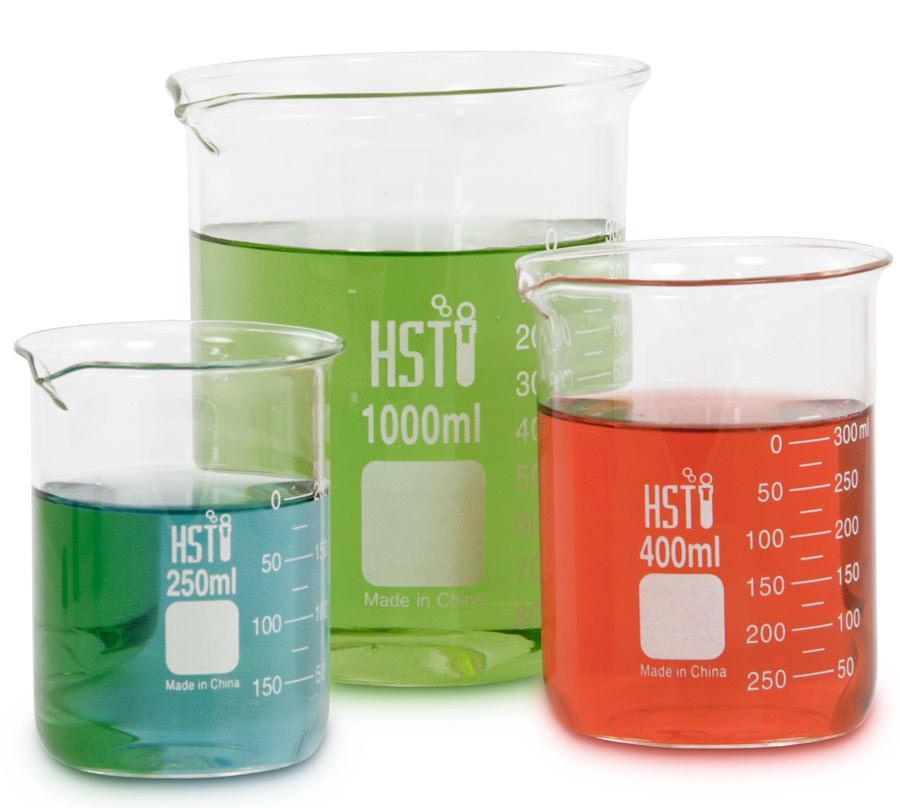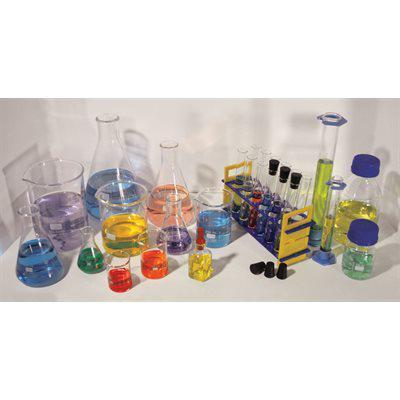The first image is the image on the left, the second image is the image on the right. Assess this claim about the two images: "The left and right image contains the same number of filled beckers.". Correct or not? Answer yes or no. No. The first image is the image on the left, the second image is the image on the right. Given the left and right images, does the statement "Every photo shows five containers of colored liquid with two large containers in the back and three small containers in the front." hold true? Answer yes or no. No. 